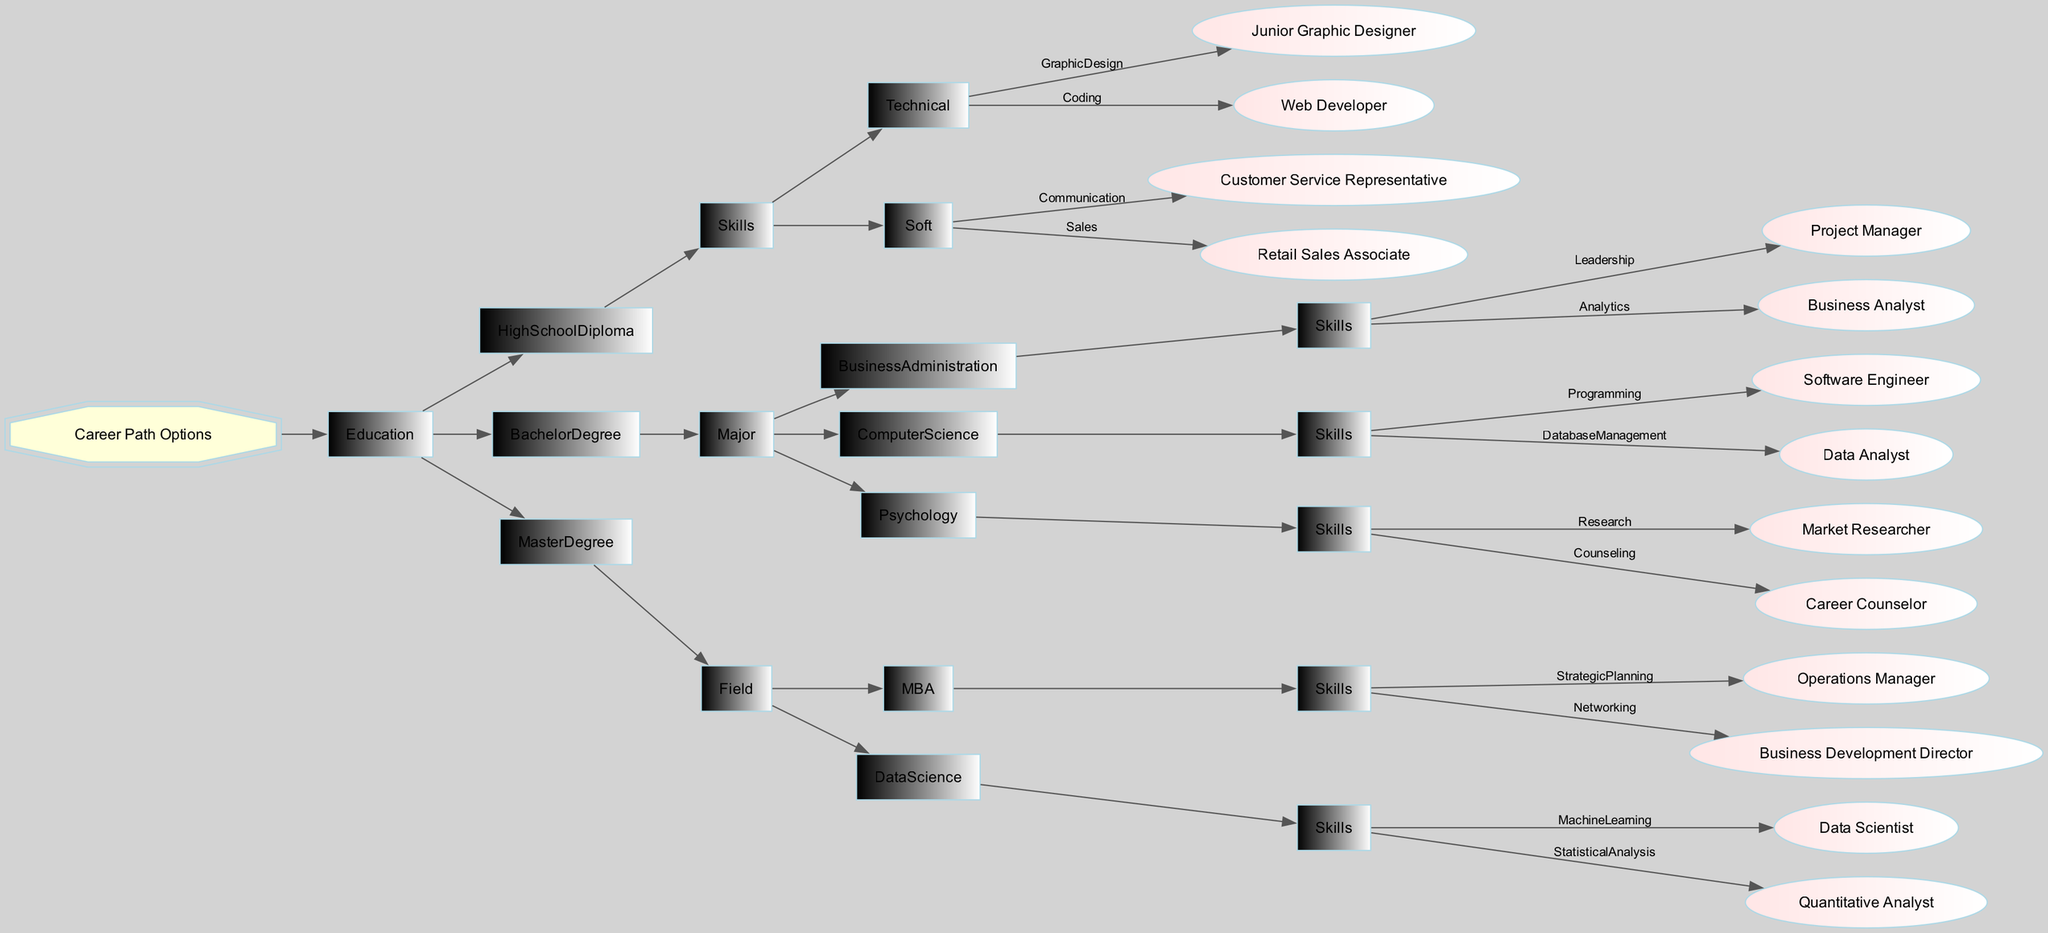What are the career options for High School Diploma graduates with Technical skills? To find the options for High School Diploma graduates with Technical skills, we locate the "HighSchoolDiploma" node in the diagram, then look under "Skills" and "Technical" to identify the listed career options, which are "Junior Graphic Designer" for Graphic Design and "Web Developer" for Coding.
Answer: Junior Graphic Designer, Web Developer How many Bachelor's Degree majors are listed? The diagram indicates the "BachelorDegree" node, which contains three sub-nodes: "BusinessAdministration," "ComputerScience," and "Psychology." Counting these sub-nodes gives us a total of three majors.
Answer: 3 Which career path is associated with the Research skill? Starting from the "BachelorDegree" node, we look for "Psychology," which specifies two skills: "Research" and "Counseling." The "Research" skill leads to the career path labeled as "Market Researcher."
Answer: Market Researcher What are the skills associated with the career of a Software Engineer? To find the skills linked to "Software Engineer," we trace back to the "BachelorDegree" section and locate the "ComputerScience" major. The corresponding skills listed under this major include "Programming," which is the skill that corresponds to the Software Engineer career path.
Answer: Programming Which education level leads to the role of Business Development Director? By examining the "MasterDegree" category, we find the "MBA" field, which includes the skill "Networking." The career associated with this skill is "Business Development Director," indicating that a Master’s Degree is required for this role.
Answer: Master Degree What is the total number of career paths listed under the Master Degree category? We start at the "MasterDegree" node and note two fields: "MBA" and "DataScience," each containing career paths associated with respective skills. "MBA" leads to two careers and "DataScience" leads to two more careers, which sums to a total of four career paths.
Answer: 4 Which skill corresponds with the role of Customer Service Representative? The career "Customer Service Representative" is associated with the "HighSchoolDiploma" node. We locate "Skills" within this node and identify the "Soft" skill labeled "Communication," which is the specific skill for this role.
Answer: Communication Which educational qualifications lead to the role of Data Scientist? The role of "Data Scientist" falls under the "MasterDegree" category, specifically within the "DataScience" field. Therefore, the educational qualification that leads to this career is a Master’s Degree in Data Science.
Answer: Master Degree in Data Science 